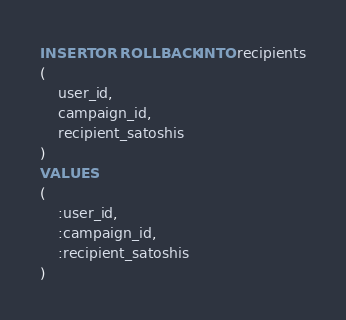<code> <loc_0><loc_0><loc_500><loc_500><_SQL_>INSERT OR ROLLBACK INTO recipients
(
	user_id,
	campaign_id,
	recipient_satoshis
)
VALUES
(
	:user_id,
	:campaign_id,
	:recipient_satoshis
)
</code> 